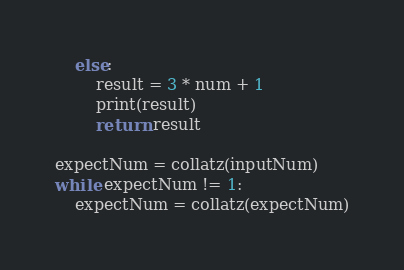Convert code to text. <code><loc_0><loc_0><loc_500><loc_500><_Python_>    else:
        result = 3 * num + 1
        print(result)
        return result

expectNum = collatz(inputNum)
while expectNum != 1:
    expectNum = collatz(expectNum)

</code> 